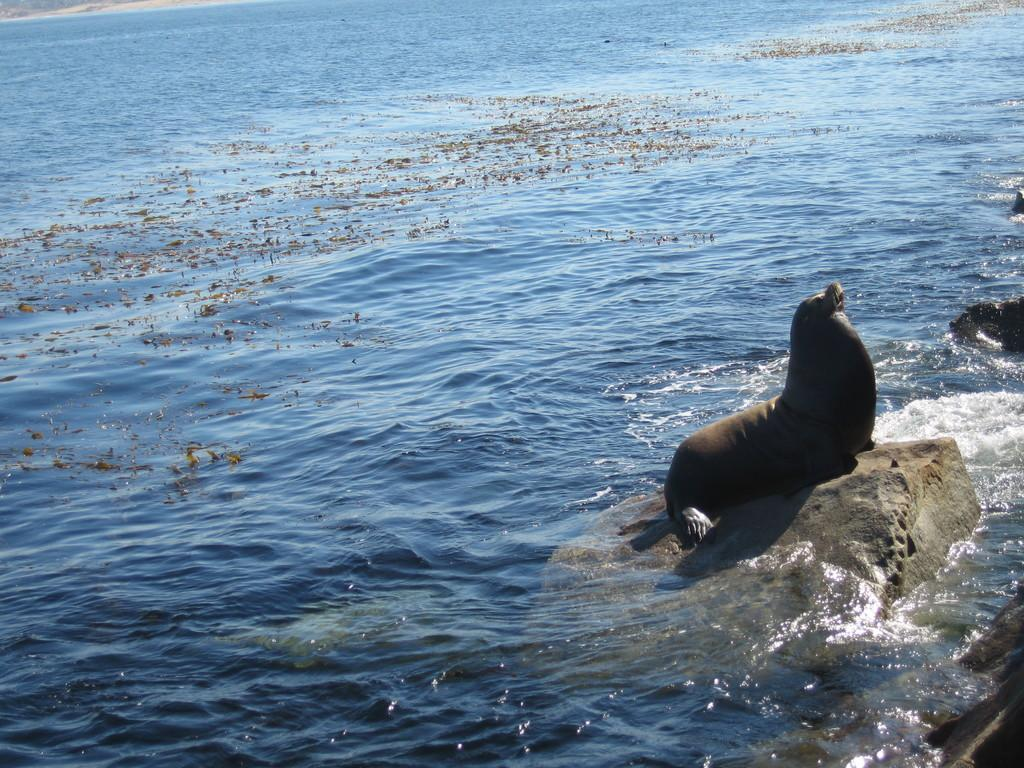What type of animal is in the image? There is a seal fish in the image. Where is the seal fish located? The seal fish is on a rock. What is the rock situated on? The rock is in the sea. What angle is the seal fish's digestive system at in the image? There is no information about the angle of the seal fish's digestive system in the image, as the focus is on the location of the seal fish and the rock. 